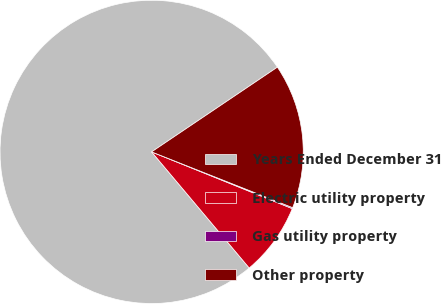Convert chart to OTSL. <chart><loc_0><loc_0><loc_500><loc_500><pie_chart><fcel>Years Ended December 31<fcel>Electric utility property<fcel>Gas utility property<fcel>Other property<nl><fcel>76.7%<fcel>7.77%<fcel>0.11%<fcel>15.43%<nl></chart> 